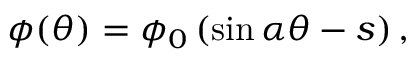Convert formula to latex. <formula><loc_0><loc_0><loc_500><loc_500>\phi ( \theta ) = \phi _ { 0 } \left ( \sin \alpha \theta - s \right ) ,</formula> 